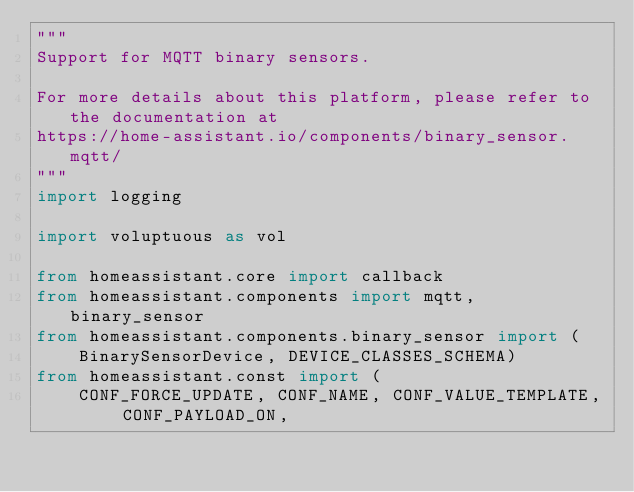Convert code to text. <code><loc_0><loc_0><loc_500><loc_500><_Python_>"""
Support for MQTT binary sensors.

For more details about this platform, please refer to the documentation at
https://home-assistant.io/components/binary_sensor.mqtt/
"""
import logging

import voluptuous as vol

from homeassistant.core import callback
from homeassistant.components import mqtt, binary_sensor
from homeassistant.components.binary_sensor import (
    BinarySensorDevice, DEVICE_CLASSES_SCHEMA)
from homeassistant.const import (
    CONF_FORCE_UPDATE, CONF_NAME, CONF_VALUE_TEMPLATE, CONF_PAYLOAD_ON,</code> 